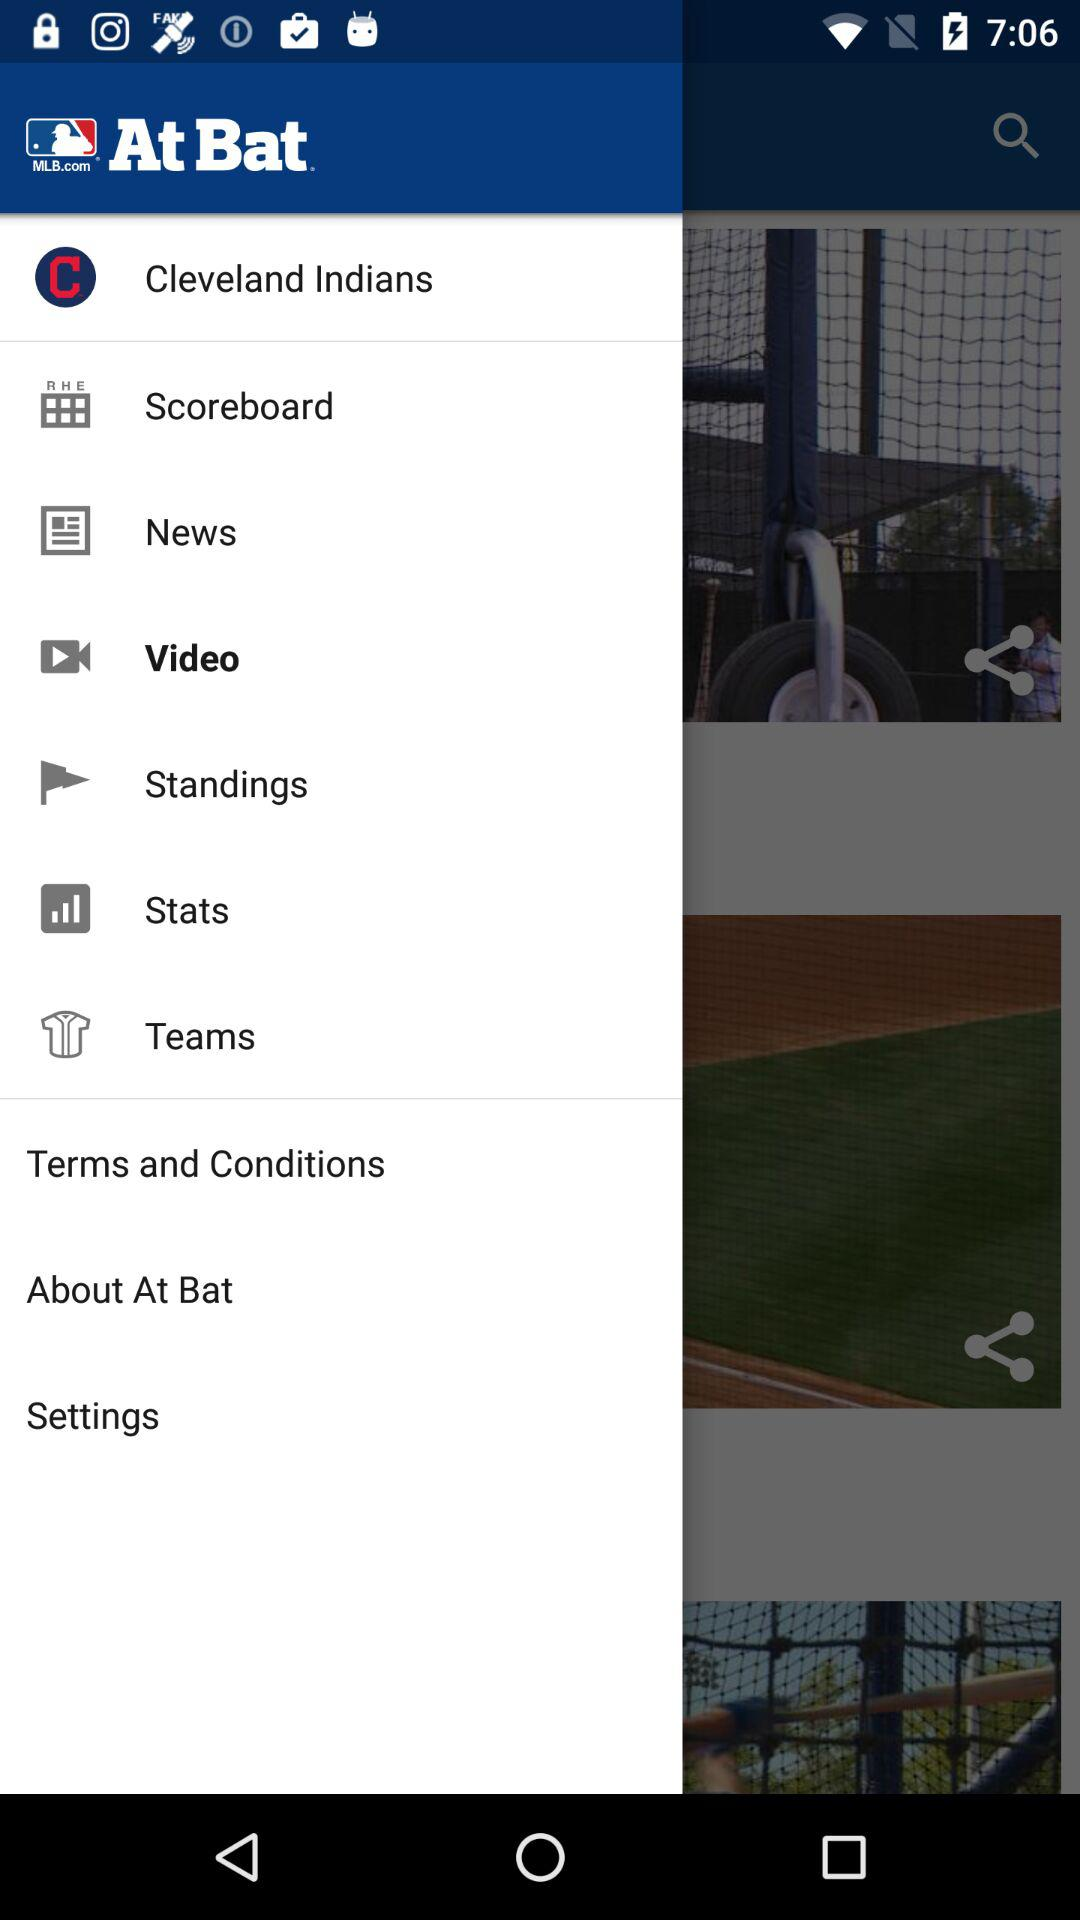How many notifications are there in "News"?
When the provided information is insufficient, respond with <no answer>. <no answer> 